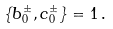<formula> <loc_0><loc_0><loc_500><loc_500>\left \{ b _ { 0 } ^ { \pm } , c _ { 0 } ^ { \pm } \right \} = 1 \, .</formula> 